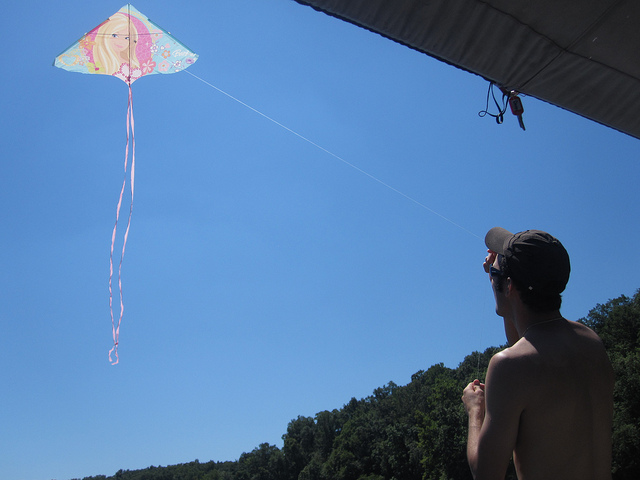What do you think is the significance of kite flying in this context? Kite flying in this context may signify a leisurely pursuit, a moment of relaxation, or a personal pastime. It could also be a way to connect with nature, enjoying the wind and openness of the sky, offering a sense of freedom and tranquillity. 